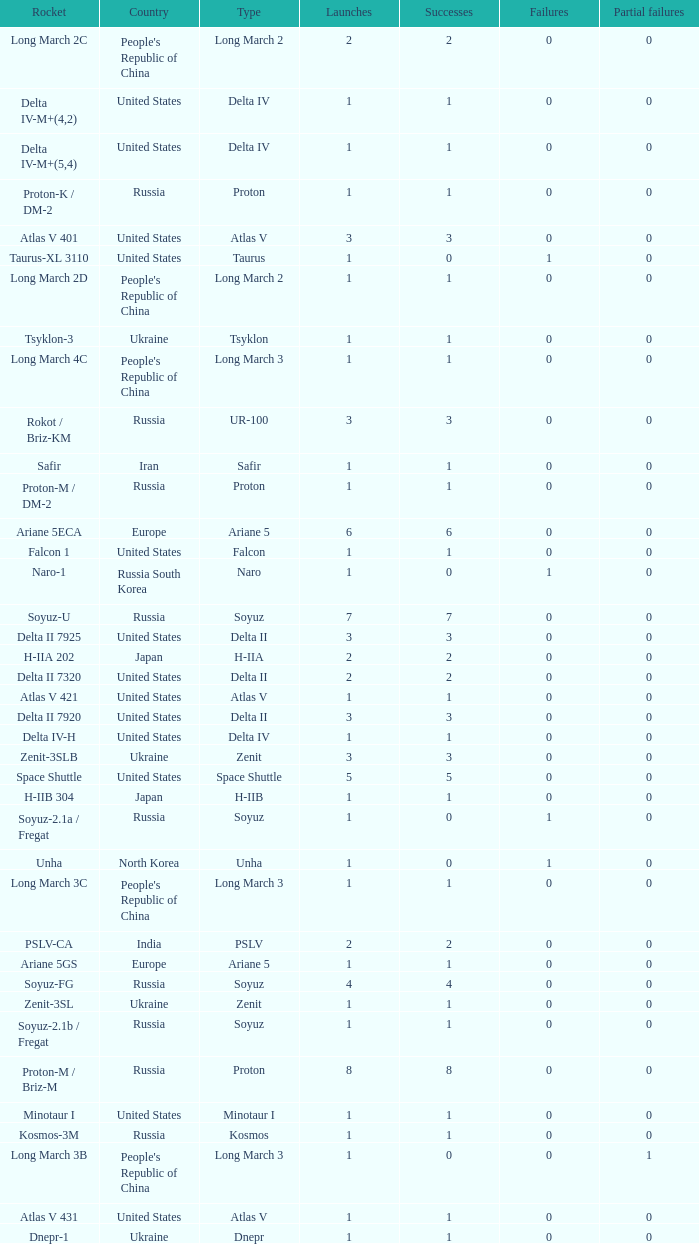What is the number of successes for rockets that have more than 3 launches, were based in Russia, are type soyuz and a rocket type of soyuz-u? 1.0. 